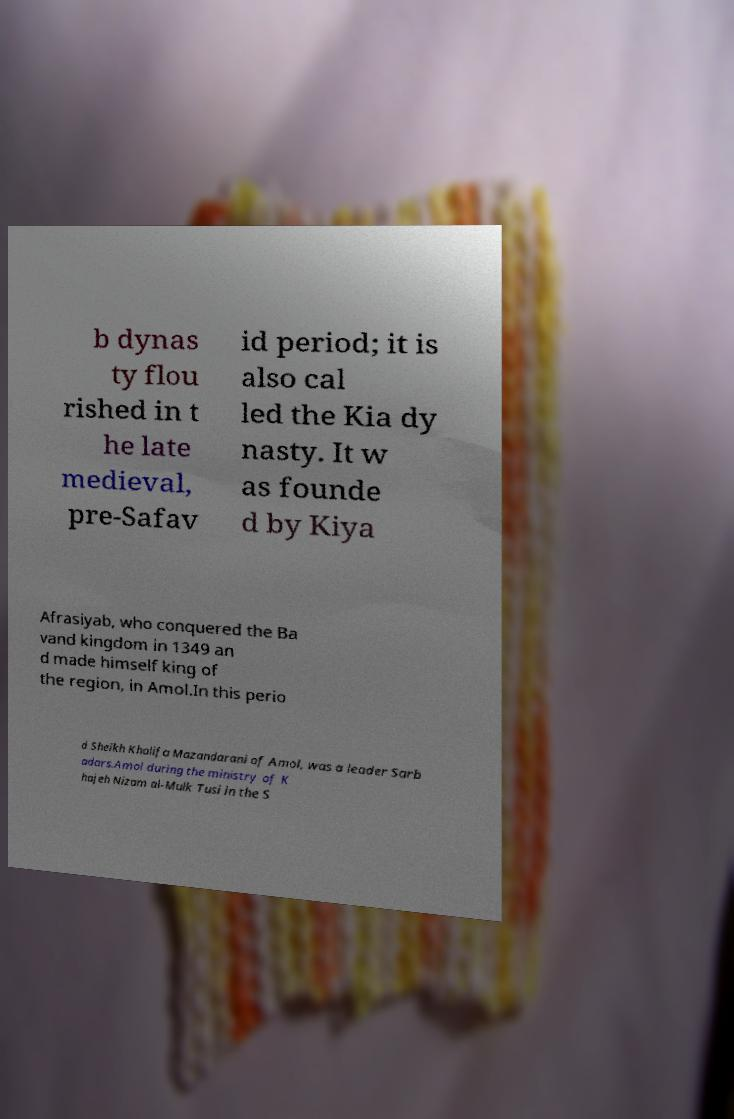I need the written content from this picture converted into text. Can you do that? b dynas ty flou rished in t he late medieval, pre-Safav id period; it is also cal led the Kia dy nasty. It w as founde d by Kiya Afrasiyab, who conquered the Ba vand kingdom in 1349 an d made himself king of the region, in Amol.In this perio d Sheikh Khalifa Mazandarani of Amol, was a leader Sarb adars.Amol during the ministry of K hajeh Nizam al-Mulk Tusi in the S 